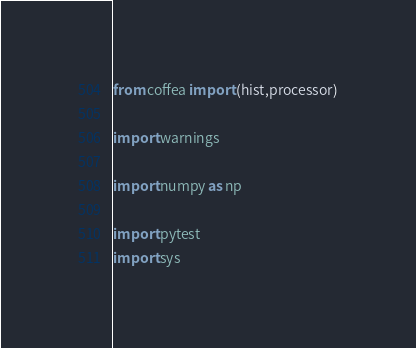Convert code to text. <code><loc_0><loc_0><loc_500><loc_500><_Python_>from coffea import (hist,processor)

import warnings

import numpy as np

import pytest
import sys
</code> 